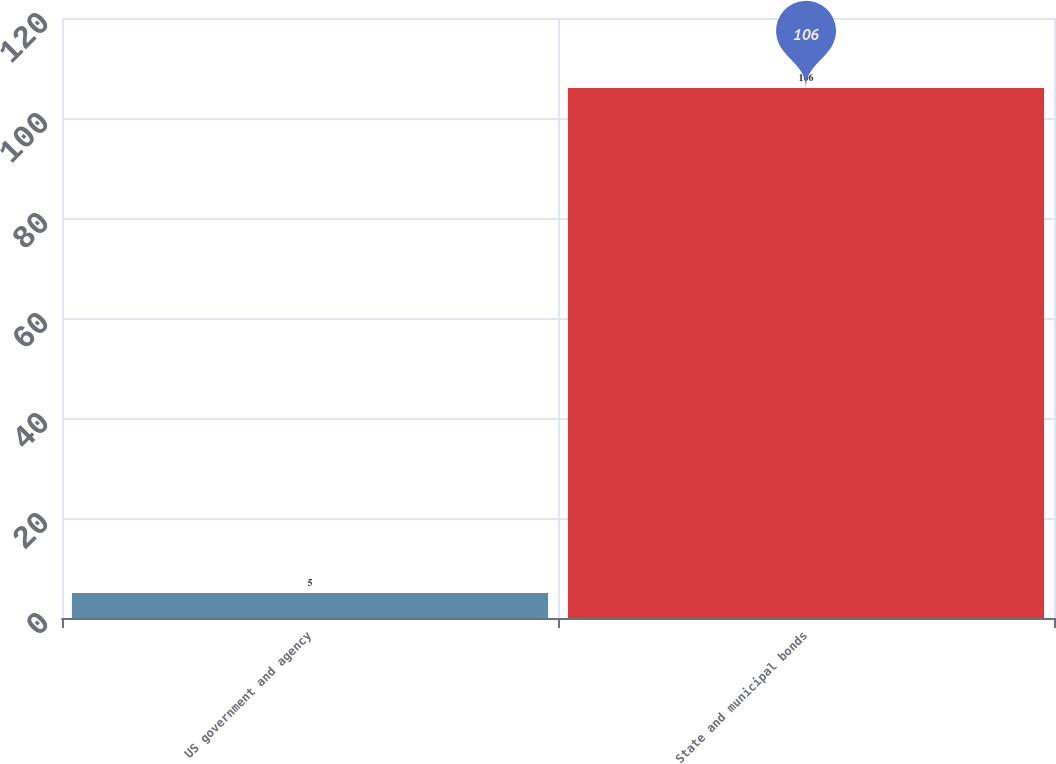Convert chart to OTSL. <chart><loc_0><loc_0><loc_500><loc_500><bar_chart><fcel>US government and agency<fcel>State and municipal bonds<nl><fcel>5<fcel>106<nl></chart> 